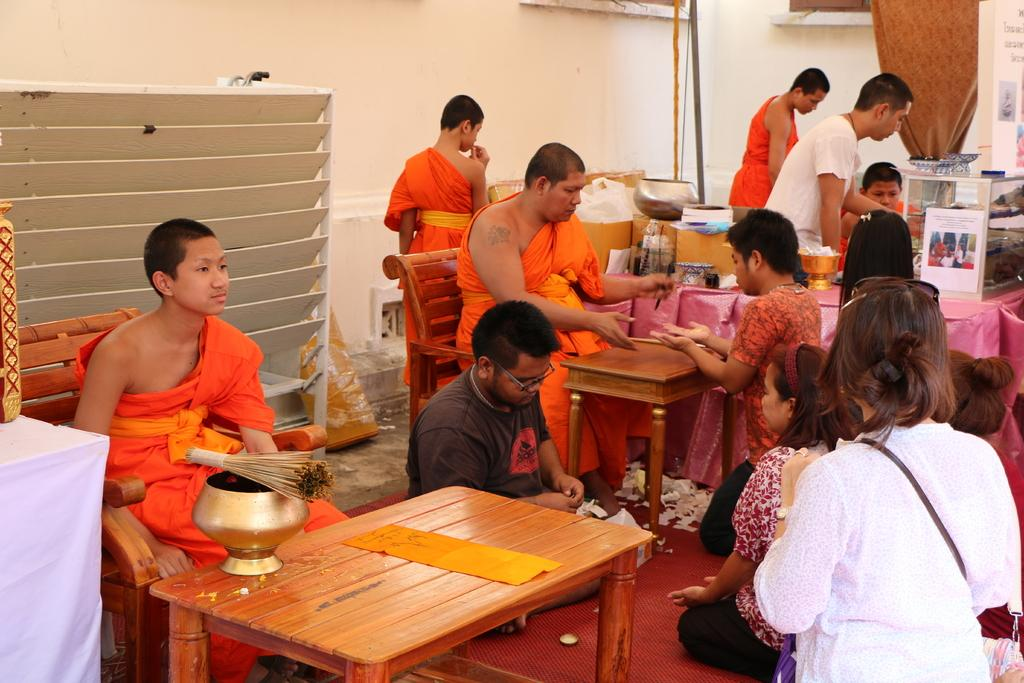What is the main subject of the image? The main subject of the image is a group of saints. What are the saints doing in the image? The saints are sitting in chairs in the image. What else can be seen in the image besides the saints? There is a table and a group of people in front of the saints in the image. What type of actor is performing in the image? There is no actor or performance present in the image; it features a group of saints sitting in chairs. What is the group of people rubbing together in the image? There is no group of people rubbing anything together in the image; they are simply standing in front of the saints. 